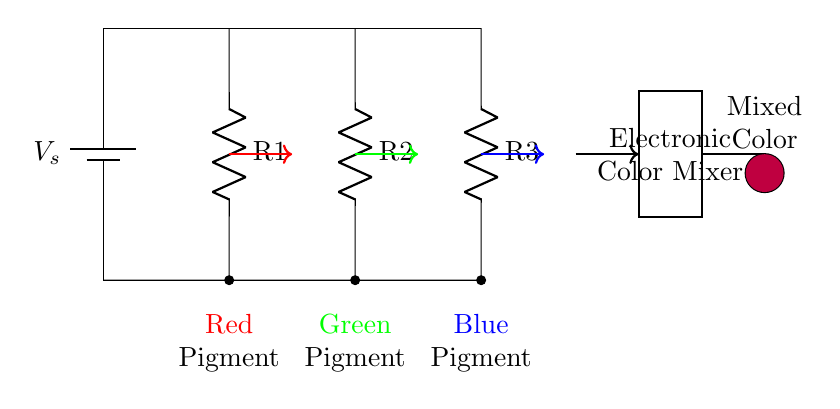What is the voltage source in this circuit? The voltage source is marked as V_s, and it provides the necessary potential difference for the circuit.
Answer: V_s How many resistors are present in the circuit diagram? The diagram shows three resistors labeled R1, R2, and R3.
Answer: 3 Which pigment corresponds to the resistor R2? The pigment corresponding to resistor R2 is green, as indicated by its label and color.
Answer: Green What role do resistors R1, R2, and R3 play in the circuit? These resistors divide the current based on their resistance values, allowing for a proportional distribution of current to each pigment.
Answer: Current division If R1 is twice the resistance of R2, which pigment will receive the most current? Since R1 is greater than R2, it will consume more voltage and lead to less current flowing through it; therefore, the pigment with the lowest resistance (R2) will receive the most current.
Answer: Green pigment What color is the mixed output at the end of the circuit? The mixed output is purple, as shown in the circular shape that is colored purple at the end.
Answer: Purple 